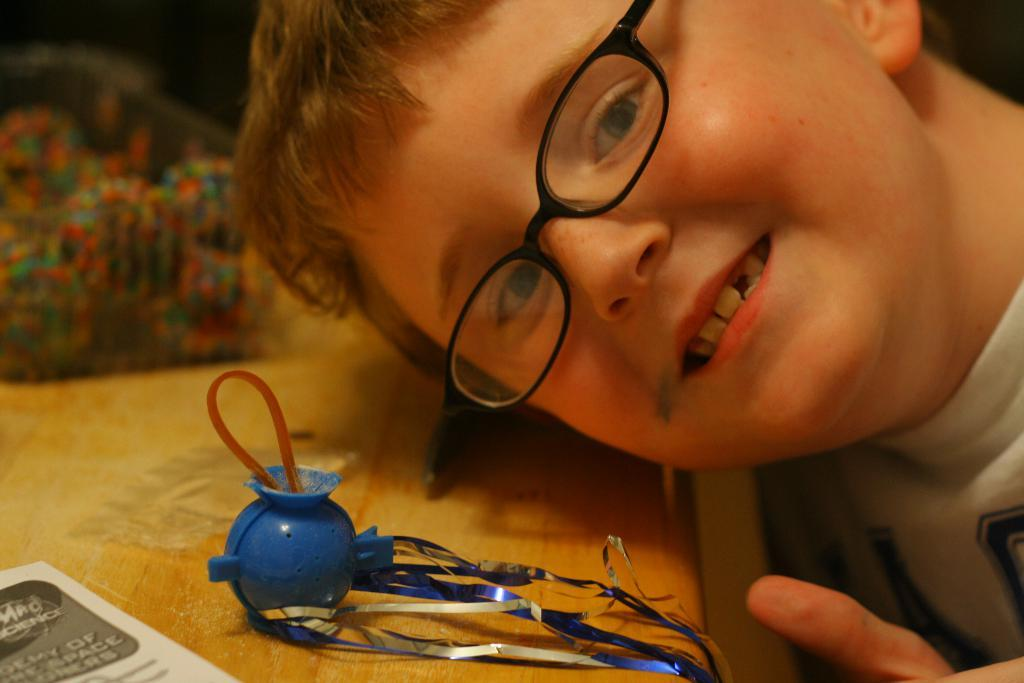What is the person in the image wearing? The person in the image is wearing a white shirt. What is in front of the person? There is a paper in front of the person. What color is the blue object on the table? The blue object on the table is not specified in the facts, so we cannot determine its color. What is the color of the table in the image? The table is brown in color. What type of hill can be seen in the background of the image? There is no hill present in the image; it only shows a person, a paper, a blue object, and a brown table. 